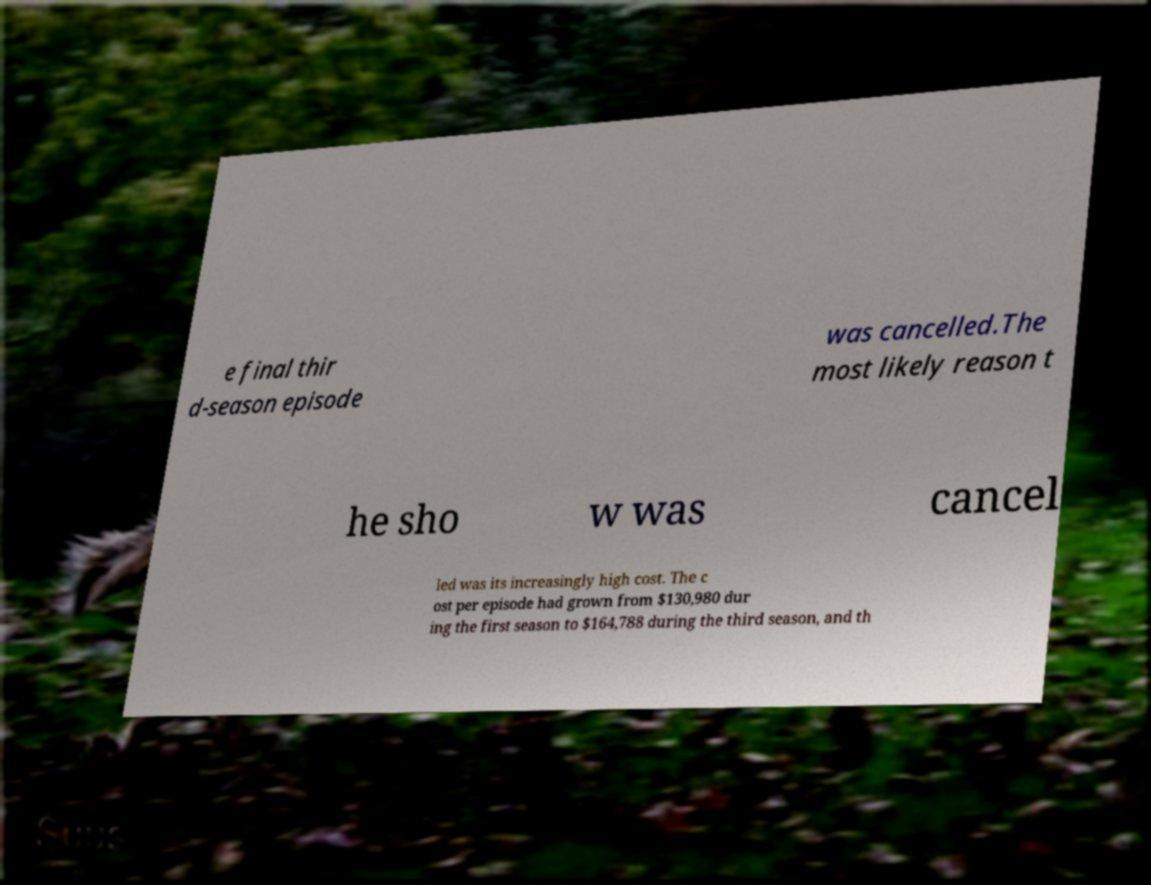Could you extract and type out the text from this image? e final thir d-season episode was cancelled.The most likely reason t he sho w was cancel led was its increasingly high cost. The c ost per episode had grown from $130,980 dur ing the first season to $164,788 during the third season, and th 